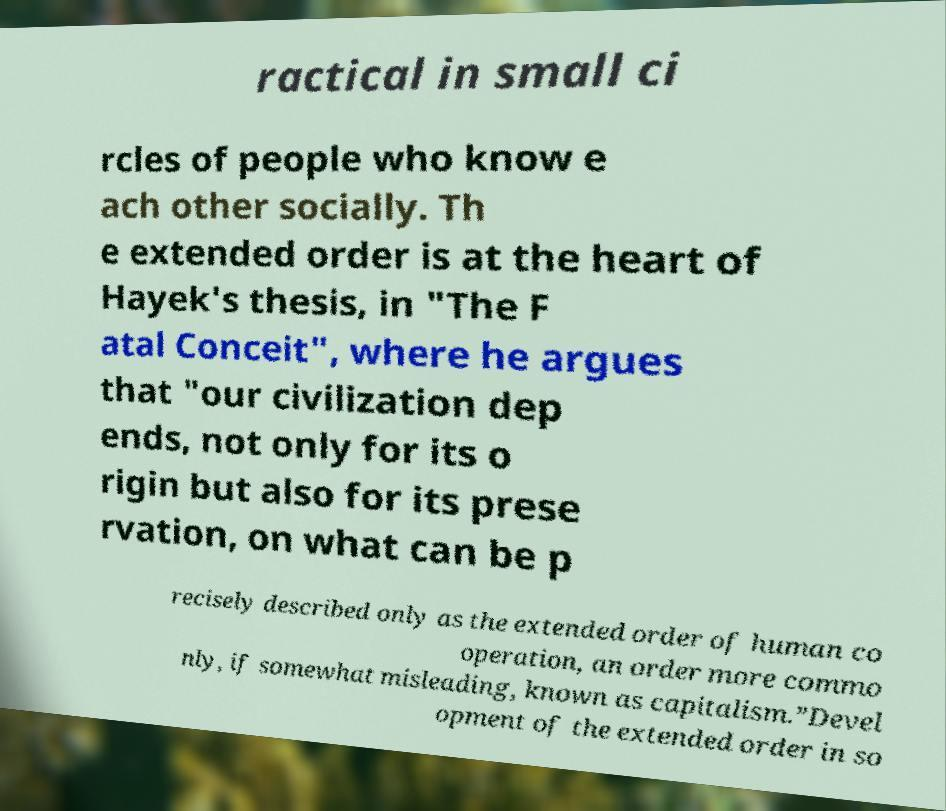Please identify and transcribe the text found in this image. ractical in small ci rcles of people who know e ach other socially. Th e extended order is at the heart of Hayek's thesis, in "The F atal Conceit", where he argues that "our civilization dep ends, not only for its o rigin but also for its prese rvation, on what can be p recisely described only as the extended order of human co operation, an order more commo nly, if somewhat misleading, known as capitalism.”Devel opment of the extended order in so 